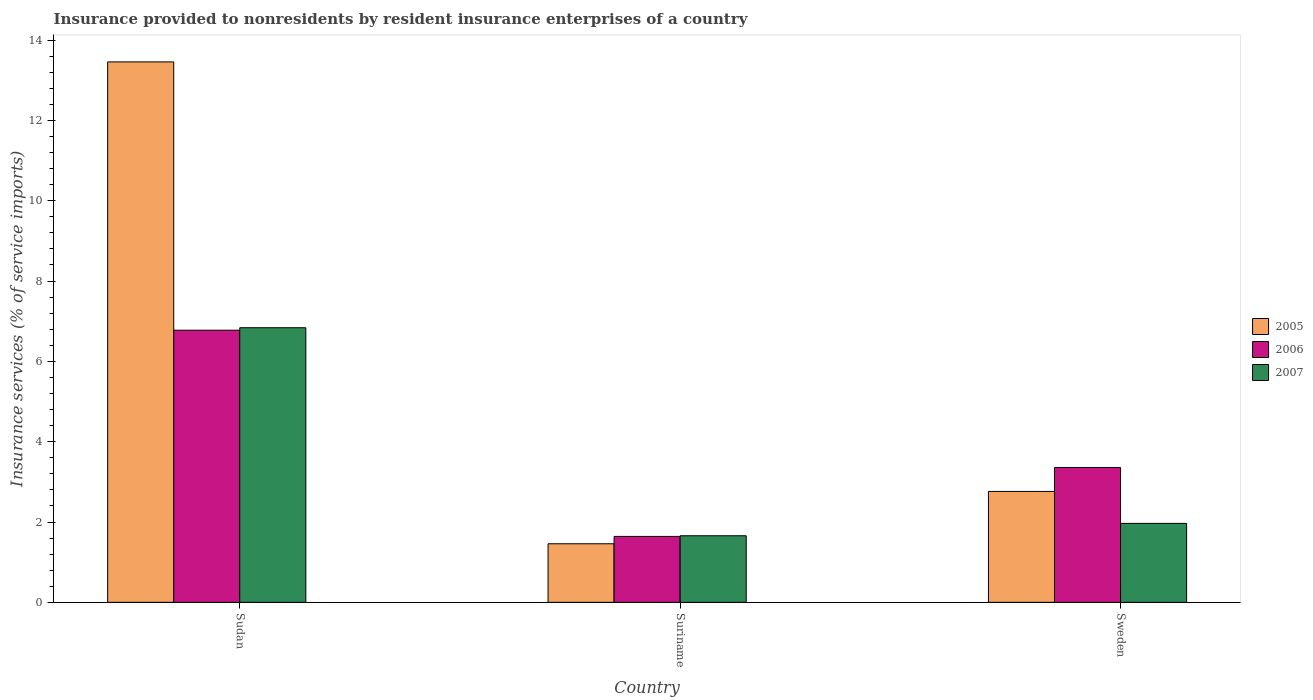How many bars are there on the 1st tick from the left?
Your answer should be compact. 3. How many bars are there on the 2nd tick from the right?
Your response must be concise. 3. What is the label of the 1st group of bars from the left?
Your response must be concise. Sudan. In how many cases, is the number of bars for a given country not equal to the number of legend labels?
Your response must be concise. 0. What is the insurance provided to nonresidents in 2005 in Sudan?
Make the answer very short. 13.46. Across all countries, what is the maximum insurance provided to nonresidents in 2006?
Provide a succinct answer. 6.78. Across all countries, what is the minimum insurance provided to nonresidents in 2006?
Make the answer very short. 1.64. In which country was the insurance provided to nonresidents in 2007 maximum?
Offer a very short reply. Sudan. In which country was the insurance provided to nonresidents in 2006 minimum?
Your response must be concise. Suriname. What is the total insurance provided to nonresidents in 2006 in the graph?
Provide a short and direct response. 11.77. What is the difference between the insurance provided to nonresidents in 2007 in Sudan and that in Suriname?
Make the answer very short. 5.18. What is the difference between the insurance provided to nonresidents in 2006 in Sudan and the insurance provided to nonresidents in 2007 in Suriname?
Your answer should be compact. 5.12. What is the average insurance provided to nonresidents in 2005 per country?
Your answer should be compact. 5.89. What is the difference between the insurance provided to nonresidents of/in 2006 and insurance provided to nonresidents of/in 2007 in Sudan?
Offer a very short reply. -0.06. In how many countries, is the insurance provided to nonresidents in 2005 greater than 10.8 %?
Give a very brief answer. 1. What is the ratio of the insurance provided to nonresidents in 2007 in Sudan to that in Suriname?
Keep it short and to the point. 4.12. Is the difference between the insurance provided to nonresidents in 2006 in Sudan and Sweden greater than the difference between the insurance provided to nonresidents in 2007 in Sudan and Sweden?
Keep it short and to the point. No. What is the difference between the highest and the second highest insurance provided to nonresidents in 2005?
Your response must be concise. -1.3. What is the difference between the highest and the lowest insurance provided to nonresidents in 2006?
Your response must be concise. 5.13. In how many countries, is the insurance provided to nonresidents in 2007 greater than the average insurance provided to nonresidents in 2007 taken over all countries?
Keep it short and to the point. 1. Is the sum of the insurance provided to nonresidents in 2005 in Suriname and Sweden greater than the maximum insurance provided to nonresidents in 2007 across all countries?
Offer a terse response. No. What does the 1st bar from the right in Suriname represents?
Your response must be concise. 2007. Is it the case that in every country, the sum of the insurance provided to nonresidents in 2006 and insurance provided to nonresidents in 2007 is greater than the insurance provided to nonresidents in 2005?
Offer a very short reply. Yes. What is the difference between two consecutive major ticks on the Y-axis?
Offer a terse response. 2. Does the graph contain grids?
Ensure brevity in your answer.  No. What is the title of the graph?
Keep it short and to the point. Insurance provided to nonresidents by resident insurance enterprises of a country. What is the label or title of the Y-axis?
Provide a succinct answer. Insurance services (% of service imports). What is the Insurance services (% of service imports) in 2005 in Sudan?
Your answer should be compact. 13.46. What is the Insurance services (% of service imports) in 2006 in Sudan?
Make the answer very short. 6.78. What is the Insurance services (% of service imports) of 2007 in Sudan?
Make the answer very short. 6.84. What is the Insurance services (% of service imports) of 2005 in Suriname?
Give a very brief answer. 1.46. What is the Insurance services (% of service imports) in 2006 in Suriname?
Keep it short and to the point. 1.64. What is the Insurance services (% of service imports) in 2007 in Suriname?
Offer a very short reply. 1.66. What is the Insurance services (% of service imports) in 2005 in Sweden?
Make the answer very short. 2.76. What is the Insurance services (% of service imports) of 2006 in Sweden?
Give a very brief answer. 3.36. What is the Insurance services (% of service imports) in 2007 in Sweden?
Give a very brief answer. 1.97. Across all countries, what is the maximum Insurance services (% of service imports) in 2005?
Make the answer very short. 13.46. Across all countries, what is the maximum Insurance services (% of service imports) in 2006?
Offer a terse response. 6.78. Across all countries, what is the maximum Insurance services (% of service imports) of 2007?
Your answer should be very brief. 6.84. Across all countries, what is the minimum Insurance services (% of service imports) of 2005?
Provide a short and direct response. 1.46. Across all countries, what is the minimum Insurance services (% of service imports) of 2006?
Offer a terse response. 1.64. Across all countries, what is the minimum Insurance services (% of service imports) of 2007?
Your response must be concise. 1.66. What is the total Insurance services (% of service imports) of 2005 in the graph?
Your response must be concise. 17.67. What is the total Insurance services (% of service imports) in 2006 in the graph?
Ensure brevity in your answer.  11.77. What is the total Insurance services (% of service imports) in 2007 in the graph?
Make the answer very short. 10.46. What is the difference between the Insurance services (% of service imports) in 2005 in Sudan and that in Suriname?
Offer a very short reply. 12. What is the difference between the Insurance services (% of service imports) of 2006 in Sudan and that in Suriname?
Give a very brief answer. 5.13. What is the difference between the Insurance services (% of service imports) in 2007 in Sudan and that in Suriname?
Offer a terse response. 5.18. What is the difference between the Insurance services (% of service imports) in 2005 in Sudan and that in Sweden?
Your answer should be compact. 10.69. What is the difference between the Insurance services (% of service imports) in 2006 in Sudan and that in Sweden?
Give a very brief answer. 3.42. What is the difference between the Insurance services (% of service imports) of 2007 in Sudan and that in Sweden?
Provide a short and direct response. 4.87. What is the difference between the Insurance services (% of service imports) in 2005 in Suriname and that in Sweden?
Your answer should be very brief. -1.3. What is the difference between the Insurance services (% of service imports) in 2006 in Suriname and that in Sweden?
Ensure brevity in your answer.  -1.72. What is the difference between the Insurance services (% of service imports) of 2007 in Suriname and that in Sweden?
Give a very brief answer. -0.31. What is the difference between the Insurance services (% of service imports) of 2005 in Sudan and the Insurance services (% of service imports) of 2006 in Suriname?
Offer a terse response. 11.81. What is the difference between the Insurance services (% of service imports) of 2005 in Sudan and the Insurance services (% of service imports) of 2007 in Suriname?
Your answer should be compact. 11.8. What is the difference between the Insurance services (% of service imports) in 2006 in Sudan and the Insurance services (% of service imports) in 2007 in Suriname?
Give a very brief answer. 5.12. What is the difference between the Insurance services (% of service imports) of 2005 in Sudan and the Insurance services (% of service imports) of 2006 in Sweden?
Ensure brevity in your answer.  10.1. What is the difference between the Insurance services (% of service imports) in 2005 in Sudan and the Insurance services (% of service imports) in 2007 in Sweden?
Provide a short and direct response. 11.49. What is the difference between the Insurance services (% of service imports) in 2006 in Sudan and the Insurance services (% of service imports) in 2007 in Sweden?
Provide a short and direct response. 4.81. What is the difference between the Insurance services (% of service imports) of 2005 in Suriname and the Insurance services (% of service imports) of 2006 in Sweden?
Make the answer very short. -1.9. What is the difference between the Insurance services (% of service imports) in 2005 in Suriname and the Insurance services (% of service imports) in 2007 in Sweden?
Keep it short and to the point. -0.51. What is the difference between the Insurance services (% of service imports) of 2006 in Suriname and the Insurance services (% of service imports) of 2007 in Sweden?
Make the answer very short. -0.32. What is the average Insurance services (% of service imports) in 2005 per country?
Provide a short and direct response. 5.89. What is the average Insurance services (% of service imports) in 2006 per country?
Your response must be concise. 3.92. What is the average Insurance services (% of service imports) of 2007 per country?
Give a very brief answer. 3.49. What is the difference between the Insurance services (% of service imports) in 2005 and Insurance services (% of service imports) in 2006 in Sudan?
Keep it short and to the point. 6.68. What is the difference between the Insurance services (% of service imports) of 2005 and Insurance services (% of service imports) of 2007 in Sudan?
Offer a terse response. 6.62. What is the difference between the Insurance services (% of service imports) of 2006 and Insurance services (% of service imports) of 2007 in Sudan?
Provide a short and direct response. -0.06. What is the difference between the Insurance services (% of service imports) of 2005 and Insurance services (% of service imports) of 2006 in Suriname?
Ensure brevity in your answer.  -0.18. What is the difference between the Insurance services (% of service imports) in 2005 and Insurance services (% of service imports) in 2007 in Suriname?
Make the answer very short. -0.2. What is the difference between the Insurance services (% of service imports) of 2006 and Insurance services (% of service imports) of 2007 in Suriname?
Your answer should be very brief. -0.02. What is the difference between the Insurance services (% of service imports) in 2005 and Insurance services (% of service imports) in 2006 in Sweden?
Your answer should be very brief. -0.6. What is the difference between the Insurance services (% of service imports) in 2005 and Insurance services (% of service imports) in 2007 in Sweden?
Your answer should be compact. 0.8. What is the difference between the Insurance services (% of service imports) in 2006 and Insurance services (% of service imports) in 2007 in Sweden?
Keep it short and to the point. 1.39. What is the ratio of the Insurance services (% of service imports) in 2005 in Sudan to that in Suriname?
Provide a short and direct response. 9.23. What is the ratio of the Insurance services (% of service imports) of 2006 in Sudan to that in Suriname?
Offer a very short reply. 4.13. What is the ratio of the Insurance services (% of service imports) of 2007 in Sudan to that in Suriname?
Your answer should be very brief. 4.12. What is the ratio of the Insurance services (% of service imports) of 2005 in Sudan to that in Sweden?
Provide a succinct answer. 4.87. What is the ratio of the Insurance services (% of service imports) in 2006 in Sudan to that in Sweden?
Ensure brevity in your answer.  2.02. What is the ratio of the Insurance services (% of service imports) of 2007 in Sudan to that in Sweden?
Keep it short and to the point. 3.48. What is the ratio of the Insurance services (% of service imports) of 2005 in Suriname to that in Sweden?
Offer a terse response. 0.53. What is the ratio of the Insurance services (% of service imports) in 2006 in Suriname to that in Sweden?
Keep it short and to the point. 0.49. What is the ratio of the Insurance services (% of service imports) in 2007 in Suriname to that in Sweden?
Offer a very short reply. 0.84. What is the difference between the highest and the second highest Insurance services (% of service imports) of 2005?
Your response must be concise. 10.69. What is the difference between the highest and the second highest Insurance services (% of service imports) of 2006?
Keep it short and to the point. 3.42. What is the difference between the highest and the second highest Insurance services (% of service imports) in 2007?
Make the answer very short. 4.87. What is the difference between the highest and the lowest Insurance services (% of service imports) of 2005?
Your answer should be very brief. 12. What is the difference between the highest and the lowest Insurance services (% of service imports) of 2006?
Provide a succinct answer. 5.13. What is the difference between the highest and the lowest Insurance services (% of service imports) in 2007?
Ensure brevity in your answer.  5.18. 